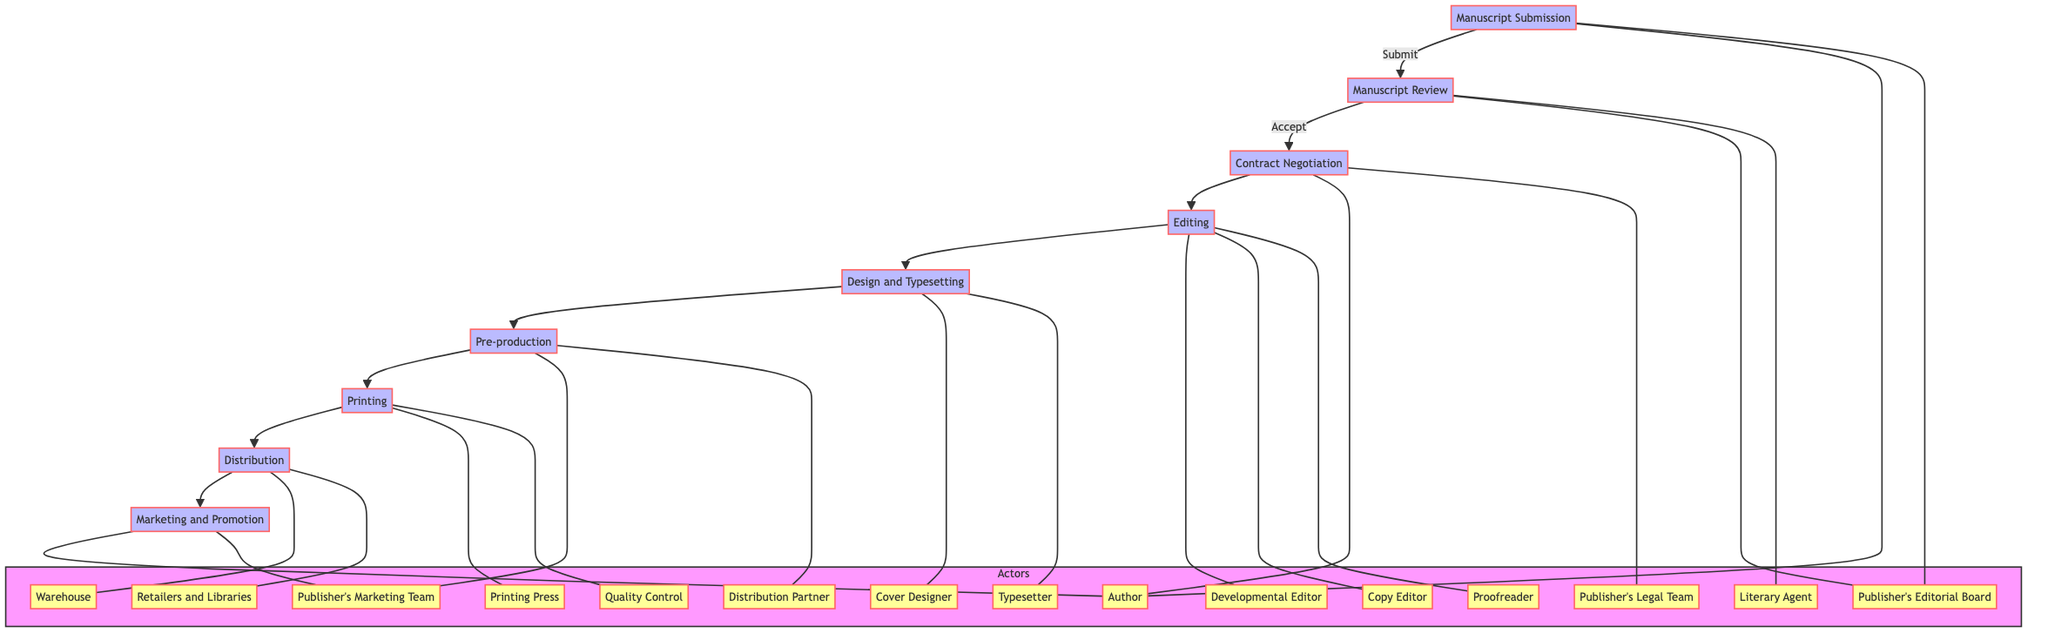What is the first step in the publishing workflow? The first step, as indicated in the diagram, is "Manuscript Submission", where the author submits their manuscript to the publisher's editorial board.
Answer: Manuscript Submission Who reviews the manuscript after submission? The manuscript is reviewed by the "Publisher's Editorial Board" after submission, as shown by the flow connecting the submission node to the review node.
Answer: Publisher's Editorial Board How many main stages are there in the publishing process? The diagram displays a total of eight main stages in the publishing process, which can be counted from the nodes: Manuscript Submission, Manuscript Review, Contract Negotiation, Editing, Design and Typesetting, Pre-production, Printing, Distribution, and Marketing and Promotion.
Answer: Eight Which team negotiates contract terms with the author? The "Publisher's Legal Team" is responsible for negotiating contract terms with the author, as we see in the Contract Negotiation section.
Answer: Publisher's Legal Team Which role is responsible for the final check for errors? The "Proofreader" is responsible for conducting the final check for errors in the Editing stage, according to the diagram.
Answer: Proofreader What occurs immediately after the "Manuscript Review"? After the "Manuscript Review", the process moves to "Contract Negotiation", indicating that once a manuscript is accepted, contract discussions take place next.
Answer: Contract Negotiation Identify the distribution channel for books after printing. The books are distributed to "Retailers and Libraries", as shown in the Distribution stage, which directly follows the Printing stage.
Answer: Retailers and Libraries What is the role of the Developmental Editor? The Developmental Editor's role is to "Work on Structure and Content" in the Editing stage, highlighting their involvement in improving the manuscript's content and structure.
Answer: Work on Structure and Content Which team creates promotional materials before production? The "Publisher's Marketing Team" is tasked with creating promotional materials in the Pre-production stage, as indicated in the diagram.
Answer: Publisher's Marketing Team 